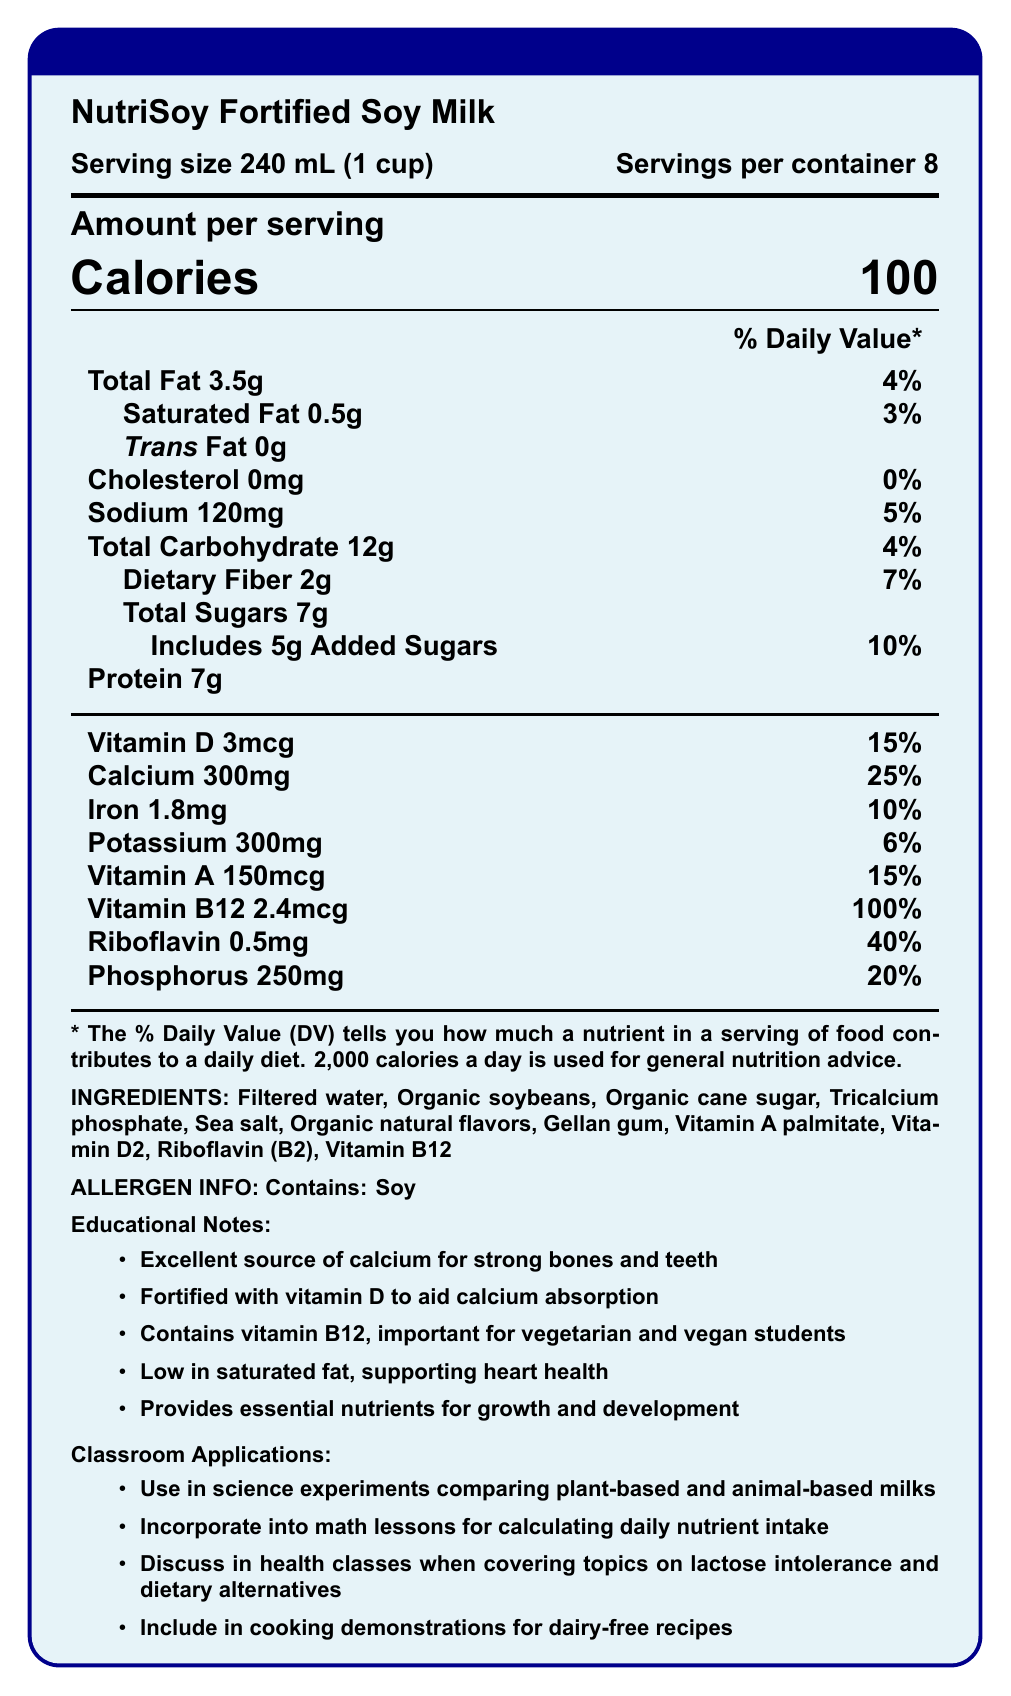what is the serving size for NutriSoy Fortified Soy Milk? The serving size is explicitly mentioned in the nutrition facts section of the document as "240 mL (1 cup)".
Answer: 240 mL (1 cup) how many servings are there per container? The document states that there are 8 servings per container under the nutrition facts.
Answer: 8 how many grams of total fat are in one serving? The amount of total fat per serving is listed under the nutrition facts section as "Total Fat 3.5g".
Answer: 3.5g what is the percentage daily value of calcium per serving? The document details that the % daily value of calcium for one serving is 25%.
Answer: 25% how much added sugar is included in one serving? The amount of added sugars per serving is mentioned in the nutrition facts as "Includes 5g Added Sugars".
Answer: 5g what is the main allergen present in NutriSoy Fortified Soy Milk? The allergen information section of the document lists "Contains: Soy".
Answer: Soy which vitamin has the highest percentage daily value per serving? A. Vitamin D B. Vitamin A C. Vitamin B12 D. Riboflavin The percentage daily values listed show that Vitamin B12 has the highest at 100%, followed by Riboflavin at 40% and the other options lower.
Answer: C. Vitamin B12 what is the main purpose of fortifying NutriSoy Fortified Soy Milk with vitamin D? A. To improve taste B. To aid calcium absorption C. To increase protein content D. To sweeten the milk The educational notes specifically mention that the milk is "Fortified with vitamin D to aid calcium absorption".
Answer: B. To aid calcium absorption is NutriSoy Fortified Soy Milk suitable for those avoiding cholesterol in their diet? The document highlights that the product contains 0mg of cholesterol per serving.
Answer: Yes summarize the main characteristics and benefits of NutriSoy Fortified Soy Milk as described in the document. The document provides details on nutritional content, health benefits, and potential classroom uses of NutriSoy Fortified Soy Milk, highlighting its beneficial nutrients and suitability for lactose-intolerant individuals.
Answer: NutriSoy Fortified Soy Milk is a lactose-free, vitamin-fortified milk alternative suitable for lactose-intolerant individuals. Each serving size is 240 mL with 8 servings per container, and it offers 100 calories. It contains significant nutrients such as calcium, vitamin D, vitamin B12, and riboflavin, making it beneficial for bone health and growth. It's low in saturated fat, with no trans fat or cholesterol. The product also supports various educational applications in the classroom, like science experiments and health discussions. what is the source of protein in NutriSoy Fortified Soy Milk? The list of ingredients in the document includes "Organic soybeans," which are known to be the source of protein.
Answer: Organic soybeans which nutrient has the lowest percentage daily value in NutriSoy Fortified Soy Milk? The nutrition facts show that saturated fat has the lowest percentage daily value at 3%.
Answer: Saturated Fat (3%) how can NutriSoy Fortified Soy Milk be used in a math lesson? According to the classroom applications, NutriSoy Fortified Soy Milk can be incorporated into math lessons for calculating daily nutrient intake.
Answer: For calculating daily nutrient intake does NutriSoy Fortified Soy Milk contain any trans fat? The nutrition facts show that there is 0g of trans fat per serving.
Answer: No how much vitamin B12 is in one serving? The amount of vitamin B12 per serving is listed in the document as 2.4mcg.
Answer: 2.4mcg what is the purpose of including tricalcium phosphate in NutriSoy Fortified Soy Milk? The document lists tricalcium phosphate as an ingredient but does not specify its purpose directly.
Answer: Cannot be determined 